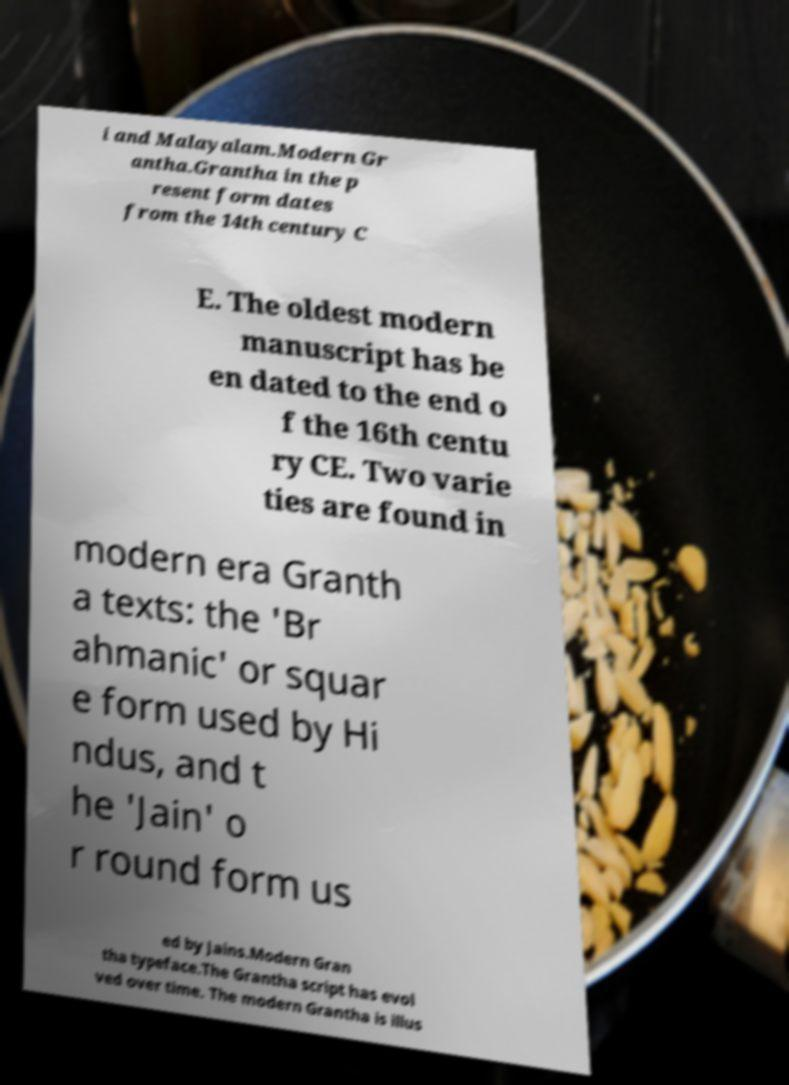I need the written content from this picture converted into text. Can you do that? i and Malayalam.Modern Gr antha.Grantha in the p resent form dates from the 14th century C E. The oldest modern manuscript has be en dated to the end o f the 16th centu ry CE. Two varie ties are found in modern era Granth a texts: the 'Br ahmanic' or squar e form used by Hi ndus, and t he 'Jain' o r round form us ed by Jains.Modern Gran tha typeface.The Grantha script has evol ved over time. The modern Grantha is illus 